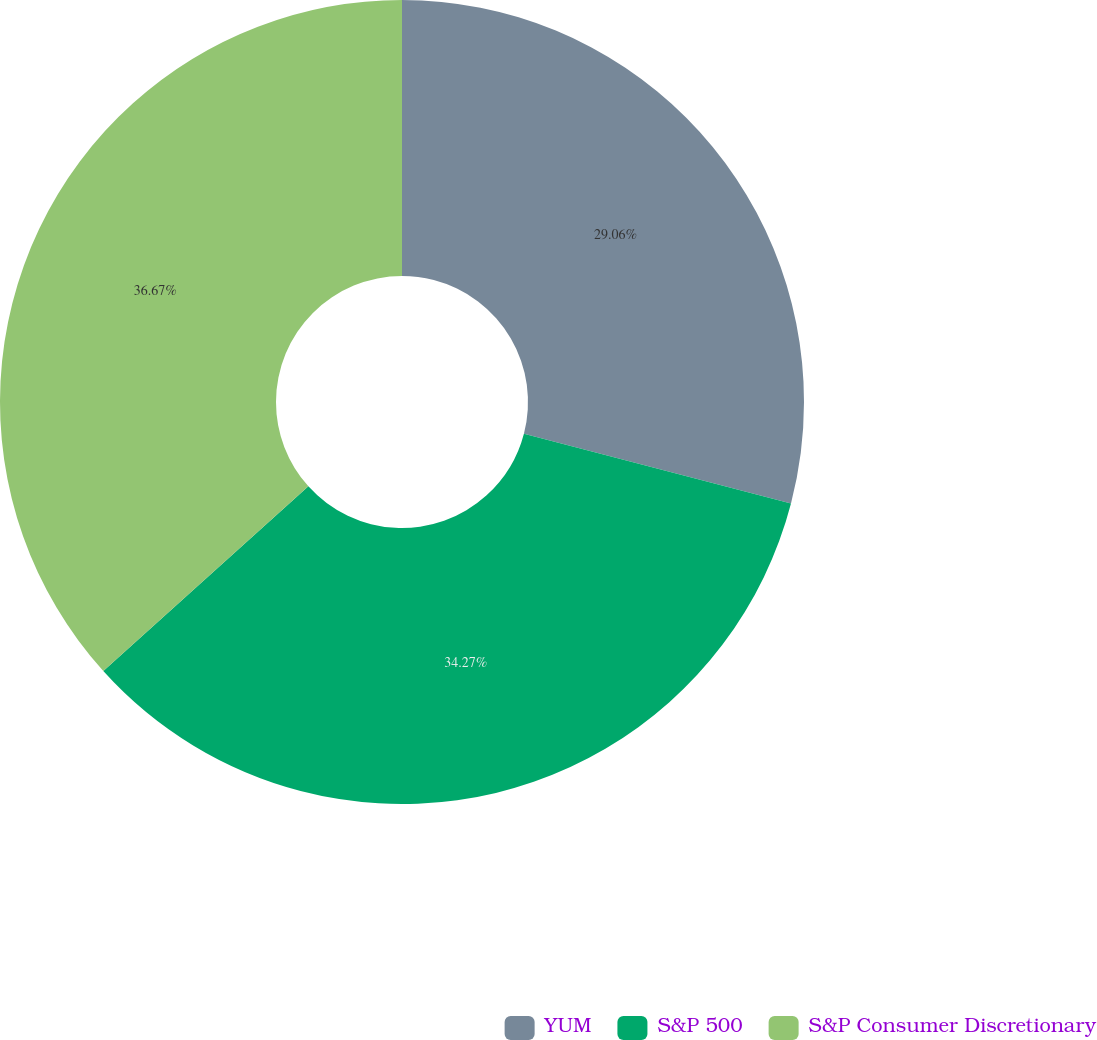Convert chart. <chart><loc_0><loc_0><loc_500><loc_500><pie_chart><fcel>YUM<fcel>S&P 500<fcel>S&P Consumer Discretionary<nl><fcel>29.06%<fcel>34.27%<fcel>36.67%<nl></chart> 